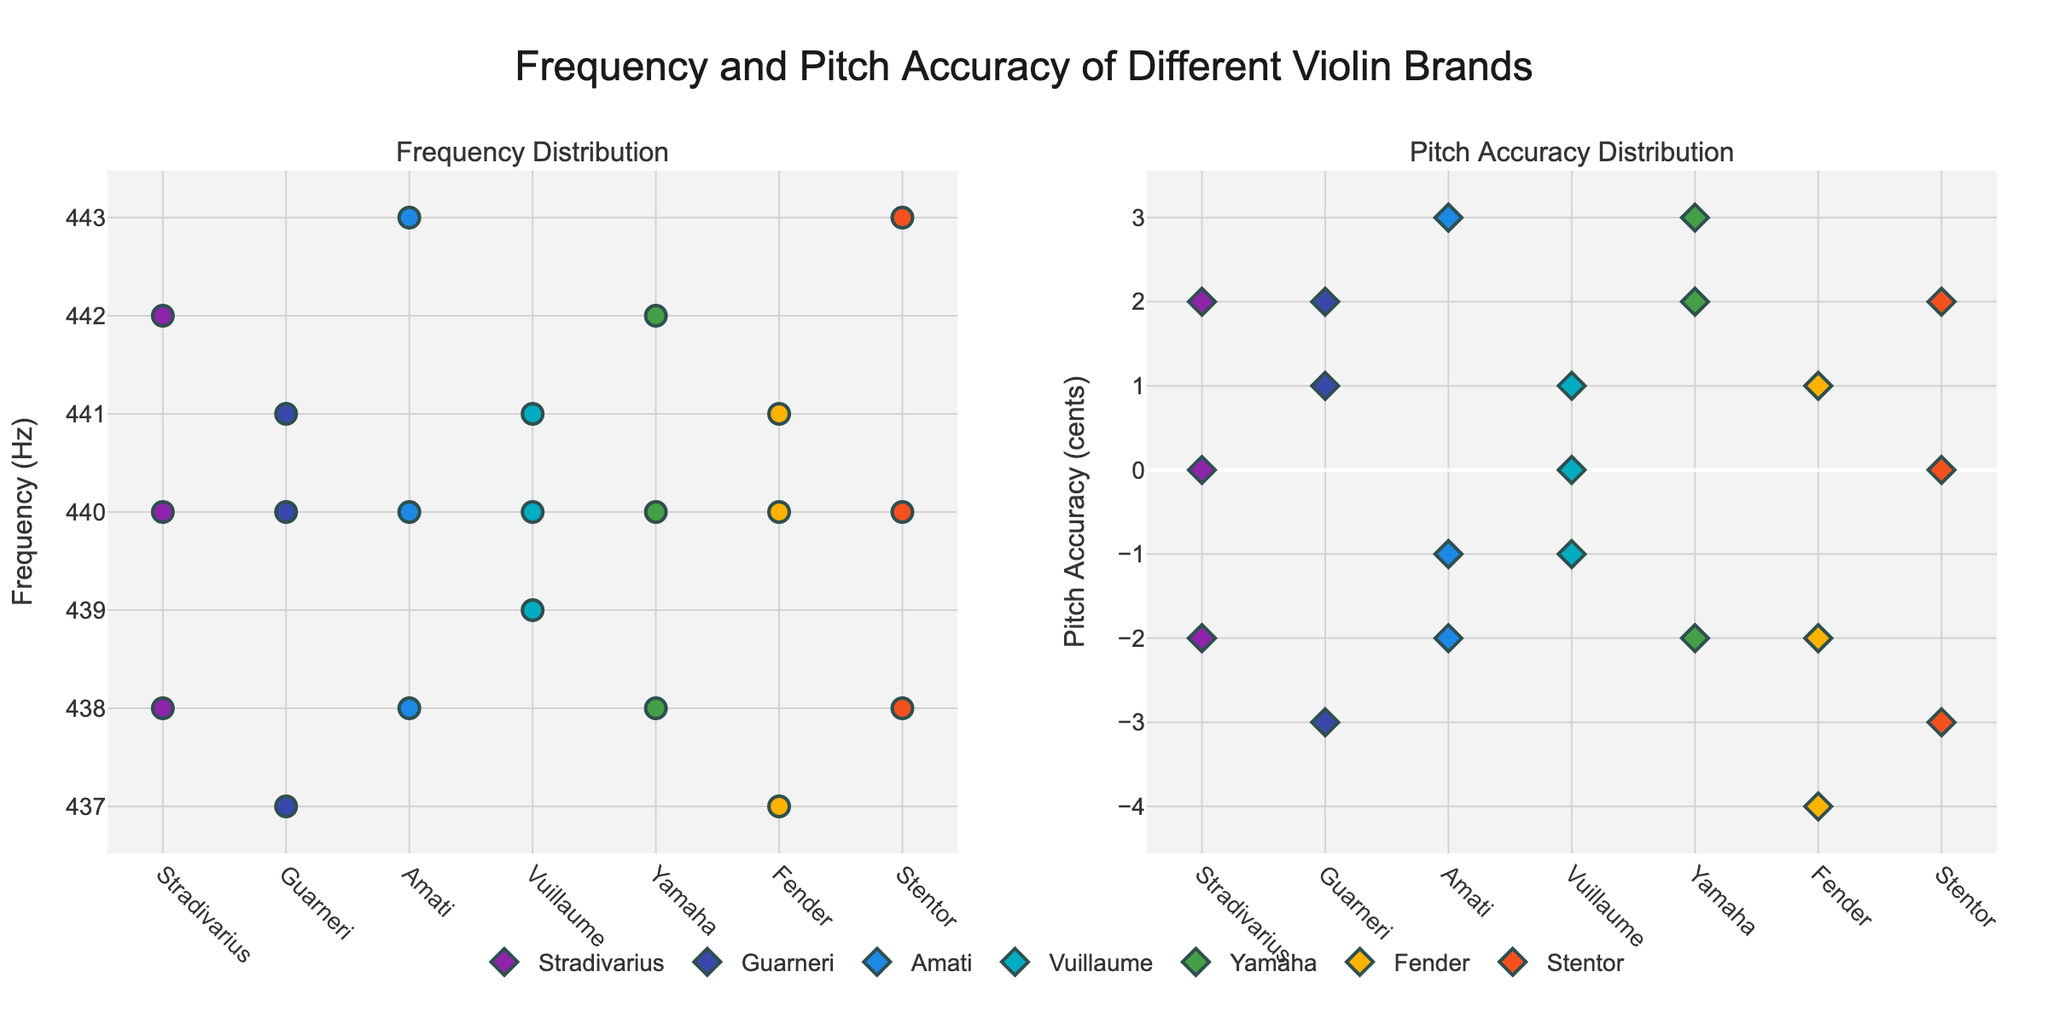What is the overall title of the figure? The title of the figure is written at the top of the plot.
Answer: "Frequency and Pitch Accuracy of Different Violin Brands in Live Performances" Which brand has the highest frequency value? By looking at the "Frequency Distribution" subplot, you can identify the brand with the highest frequency value by comparing all the data points. The highest point in the "Frequency Distribution" subplot is at 443 Hz.
Answer: Amati What is the pitch accuracy range for the Fender brand? To determine the pitch accuracy range for Fender, we review the "Pitch Accuracy Distribution" subplot. Look for the highest and lowest pitch accuracy values among the data points for Fender. The highest value is 1 cent and the lowest is -4 cents. Subtract these to find the range: 1 - (-4) = 5.
Answer: 5 cents Which brand has the best pitch accuracy (closest to 0)? To find the brand with the best pitch accuracy, examine the "Pitch Accuracy Distribution" subplot to see which brand's data points are closest to 0 cents.
Answer: Stradivarius and Vuillaume How many data points are there for each brand in the figure? To find the number of data points for each brand, count the number of markers for each brand across both subplots. Each brand has three data points as indicated by the consistent number of markers for each brand.
Answer: 3 data points per brand Which brands have a frequency exactly at 440 Hz? Review the "Frequency Distribution" subplot to see which brands have data points exactly at 440 Hz.
Answer: Stradivarius, Guarneri, Amati, Vuillaume, Yamaha, Fender, and Stentor What is the average pitch accuracy for the Guarneri brand? Look at the "Pitch Accuracy Distribution" subplot and note the pitch accuracy values for Guarneri: 1, 2, -3. Compute the average by summing these values and dividing by the number of data points: (1 + 2 + (-3))/3 = 0.
Answer: 0 cents 